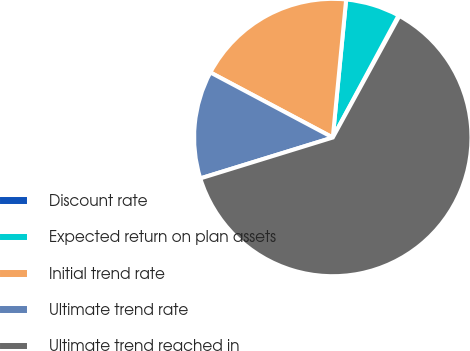Convert chart to OTSL. <chart><loc_0><loc_0><loc_500><loc_500><pie_chart><fcel>Discount rate<fcel>Expected return on plan assets<fcel>Initial trend rate<fcel>Ultimate trend rate<fcel>Ultimate trend reached in<nl><fcel>0.11%<fcel>6.33%<fcel>18.76%<fcel>12.54%<fcel>62.26%<nl></chart> 